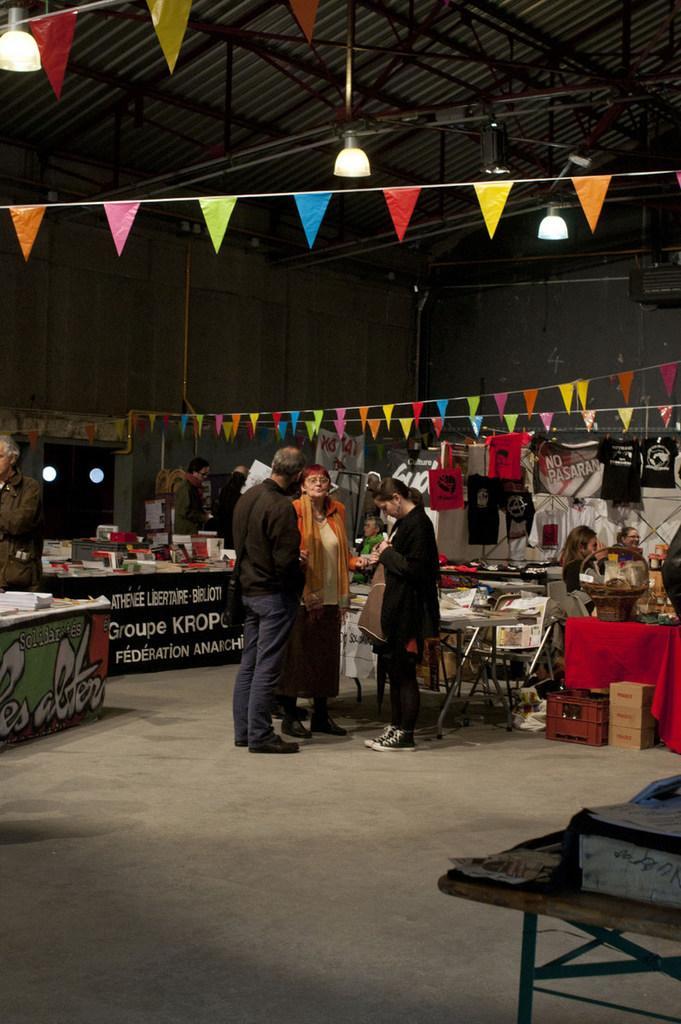In one or two sentences, can you explain what this image depicts? In this image I can see number of tables, number of people and on these tables, I can see number of stuffs. I can also see number of paper flags and few lights on the ceiling. In the background I can see two more lights. 